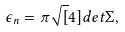Convert formula to latex. <formula><loc_0><loc_0><loc_500><loc_500>\epsilon _ { n } = \pi \sqrt { [ } 4 ] { d e t \Sigma } ,</formula> 